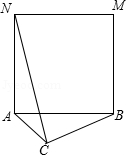What geometric properties of the square ABMN ensure that CN reaches its maximum when point C' coincides with point N? Squares possess several defining properties: all sides equal in length, and all internal angles a perfect 90 degrees. In our geometric scenario, these properties ensure that ABMN remains rigid in structure, its form unchanging as triangle ACB rotates. When we articulate triangle ACB around A to make AC' overlap with AN, it is the square's right angle at A that directs C' to follow the path of AN perfectly; the square's equal side lengths ensure that as AB extends to AN, AC' equals AC, maintaining the isosceles right triangle structure. It is these steadfast properties of the square that anchor C' to potentially unite with N, thus 'locking in' the maximum length of CN at that instance. 